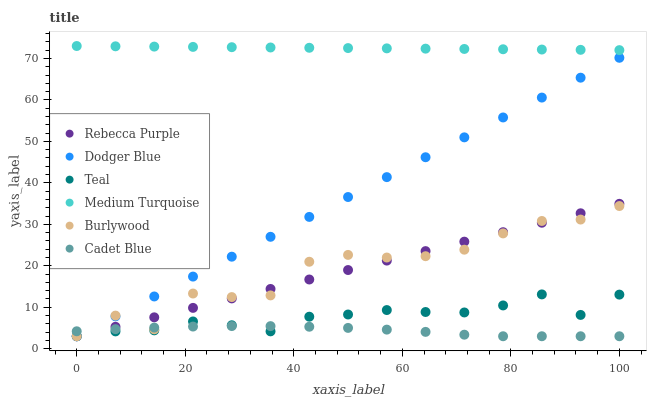Does Cadet Blue have the minimum area under the curve?
Answer yes or no. Yes. Does Medium Turquoise have the maximum area under the curve?
Answer yes or no. Yes. Does Teal have the minimum area under the curve?
Answer yes or no. No. Does Teal have the maximum area under the curve?
Answer yes or no. No. Is Rebecca Purple the smoothest?
Answer yes or no. Yes. Is Burlywood the roughest?
Answer yes or no. Yes. Is Teal the smoothest?
Answer yes or no. No. Is Teal the roughest?
Answer yes or no. No. Does Cadet Blue have the lowest value?
Answer yes or no. Yes. Does Medium Turquoise have the lowest value?
Answer yes or no. No. Does Medium Turquoise have the highest value?
Answer yes or no. Yes. Does Teal have the highest value?
Answer yes or no. No. Is Teal less than Medium Turquoise?
Answer yes or no. Yes. Is Medium Turquoise greater than Cadet Blue?
Answer yes or no. Yes. Does Dodger Blue intersect Burlywood?
Answer yes or no. Yes. Is Dodger Blue less than Burlywood?
Answer yes or no. No. Is Dodger Blue greater than Burlywood?
Answer yes or no. No. Does Teal intersect Medium Turquoise?
Answer yes or no. No. 